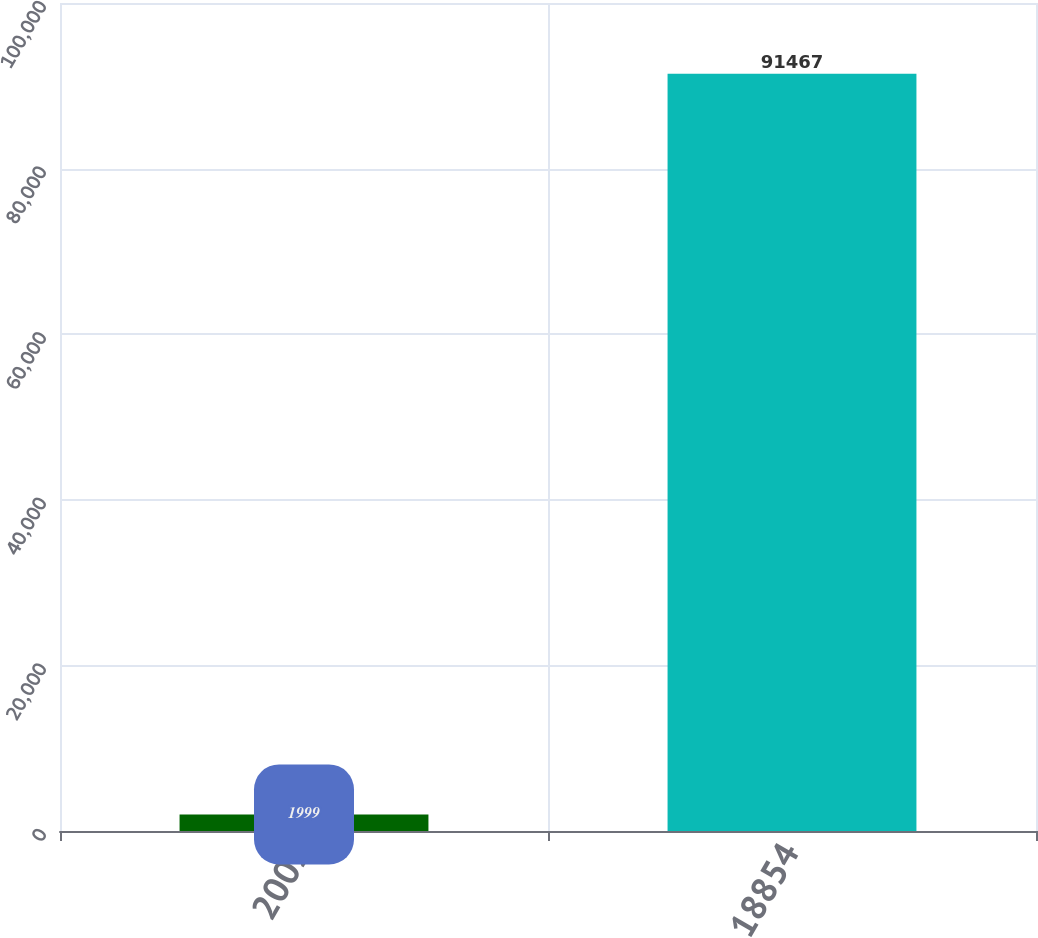<chart> <loc_0><loc_0><loc_500><loc_500><bar_chart><fcel>2002<fcel>18854<nl><fcel>1999<fcel>91467<nl></chart> 